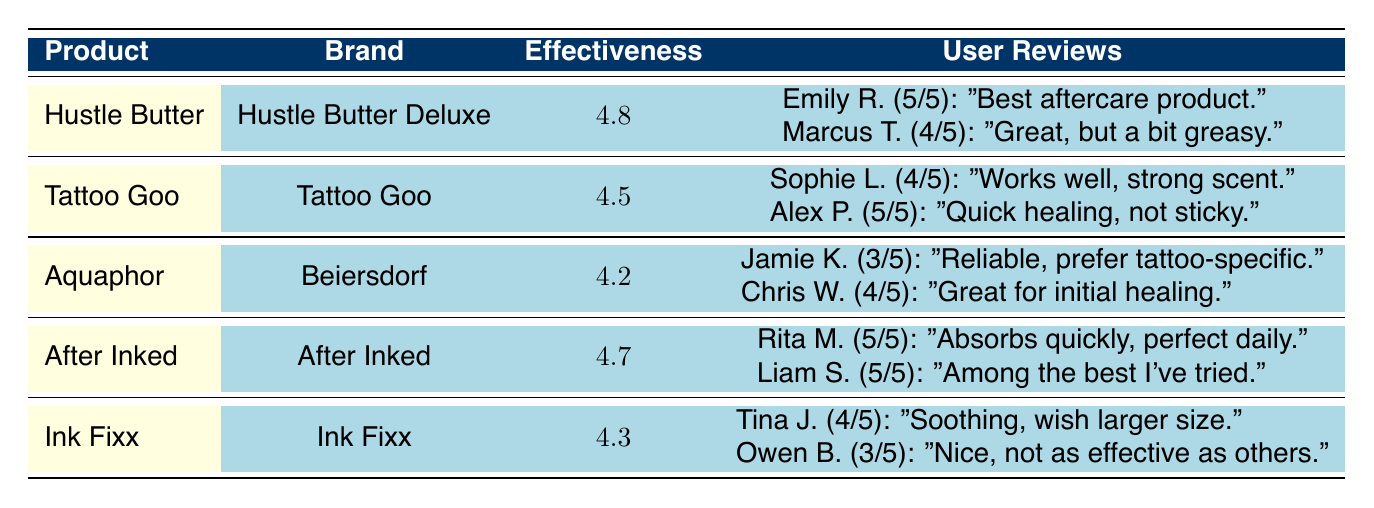What is the effectiveness rating of Hustle Butter? The effectiveness rating is directly listed in the table under the "Effectiveness" column for Hustle Butter, which shows a value of 4.8.
Answer: 4.8 How many user reviews does After Inked Moisturizer have? The table presents user reviews for After Inked Moisturizer, and there are two listed under the "User Reviews" column.
Answer: 2 Which product has the highest effectiveness rating? By comparing the effectiveness ratings in the "Effectiveness" column, Hustle Butter has the highest rating of 4.8 compared to others.
Answer: Hustle Butter Is Tattoo Goo rated higher than Ink Fixx? The effectiveness rating for Tattoo Goo is 4.5, while Ink Fixx has a rating of 4.3. Since 4.5 is greater than 4.3, Tattoo Goo has a higher rating.
Answer: Yes What is the average effectiveness rating of the products listed? To find the average, we sum the effectiveness ratings (4.8 + 4.5 + 4.2 + 4.7 + 4.3) = 22.5. There are 5 products, so the average is 22.5 / 5 = 4.5.
Answer: 4.5 How many products received a rating of 5 from users? By checking each row in the "User Reviews" for a rating of 5, both Rita M. and Liam S. gave 5 out of 5 to After Inked, and Emily R. and Alex P. rated Hustle Butter and Tattoo Goo a 5, respectively. There are a total of 4 ratings of 5 across products.
Answer: 4 Is there any product that has a review mentioning it is too greasy? Marcus T.’s review mentions that Hustle Butter is great for moisturizing but is a bit greasy, which categorizes it as having a review stating it's too greasy.
Answer: Yes Which product has a user review that mentions it’s reliable? Jamie K.'s review under Aquaphor Healing Ointment states that it is a "reliable option," indicating that this product has a review mentioning reliability.
Answer: Aquaphor Healing Ointment 